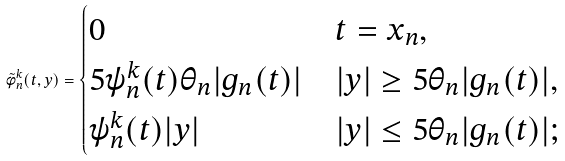Convert formula to latex. <formula><loc_0><loc_0><loc_500><loc_500>\tilde { \phi } _ { n } ^ { k } ( t , y ) = \begin{cases} 0 & t = x _ { n } , \\ 5 \psi _ { n } ^ { k } ( t ) \theta _ { n } | g _ { n } ( t ) | & | y | \geq 5 \theta _ { n } | g _ { n } ( t ) | , \\ \psi _ { n } ^ { k } ( t ) | y | & | y | \leq 5 \theta _ { n } | g _ { n } ( t ) | ; \end{cases}</formula> 